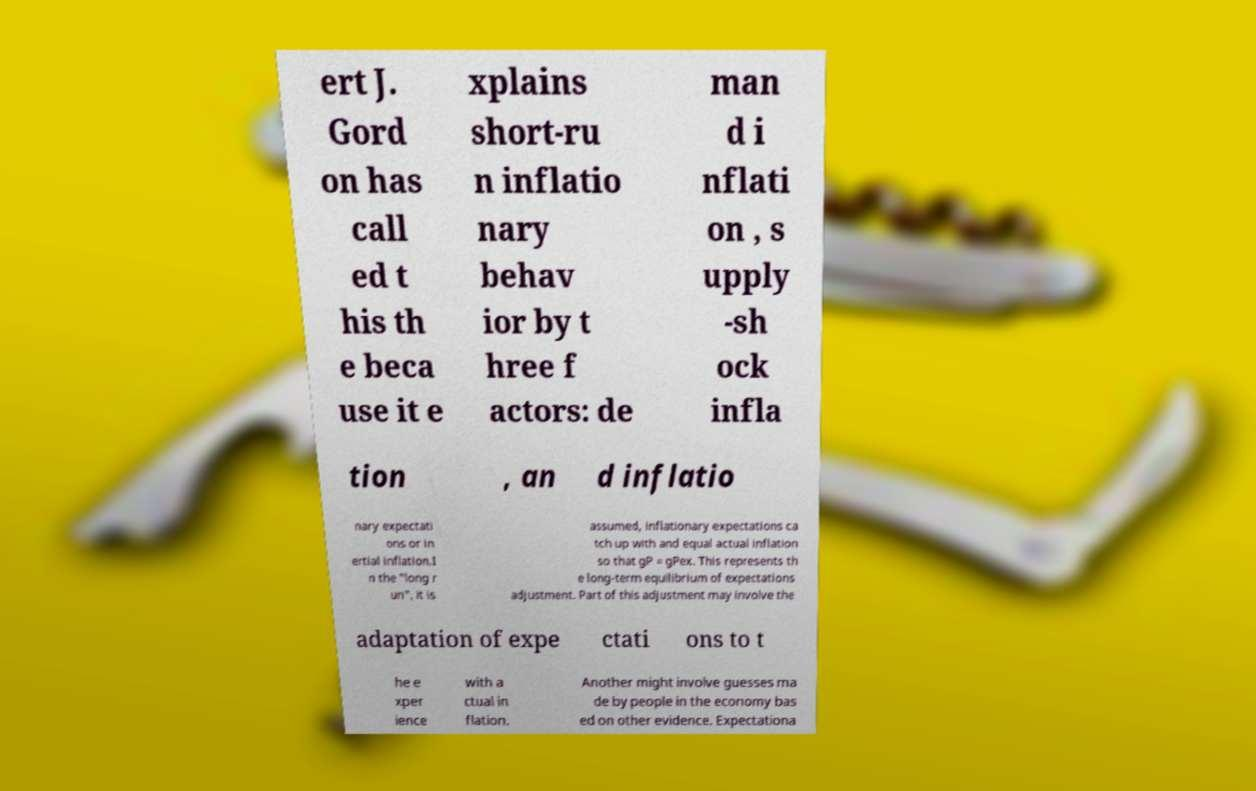Please read and relay the text visible in this image. What does it say? ert J. Gord on has call ed t his th e beca use it e xplains short-ru n inflatio nary behav ior by t hree f actors: de man d i nflati on , s upply -sh ock infla tion , an d inflatio nary expectati ons or in ertial inflation.I n the "long r un", it is assumed, inflationary expectations ca tch up with and equal actual inflation so that gP = gPex. This represents th e long-term equilibrium of expectations adjustment. Part of this adjustment may involve the adaptation of expe ctati ons to t he e xper ience with a ctual in flation. Another might involve guesses ma de by people in the economy bas ed on other evidence. Expectationa 